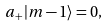Convert formula to latex. <formula><loc_0><loc_0><loc_500><loc_500>a _ { + } | m - 1 \rangle = 0 ,</formula> 